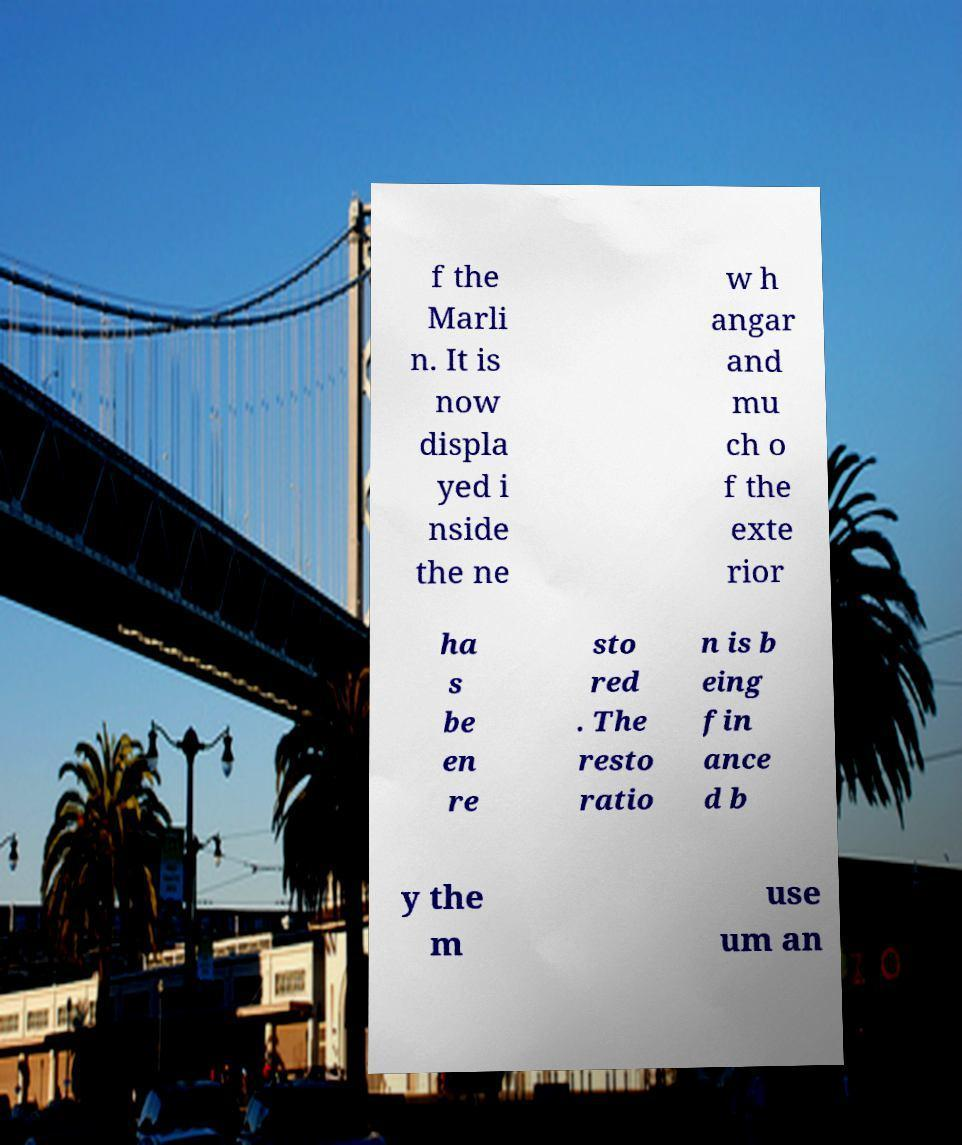Could you extract and type out the text from this image? f the Marli n. It is now displa yed i nside the ne w h angar and mu ch o f the exte rior ha s be en re sto red . The resto ratio n is b eing fin ance d b y the m use um an 